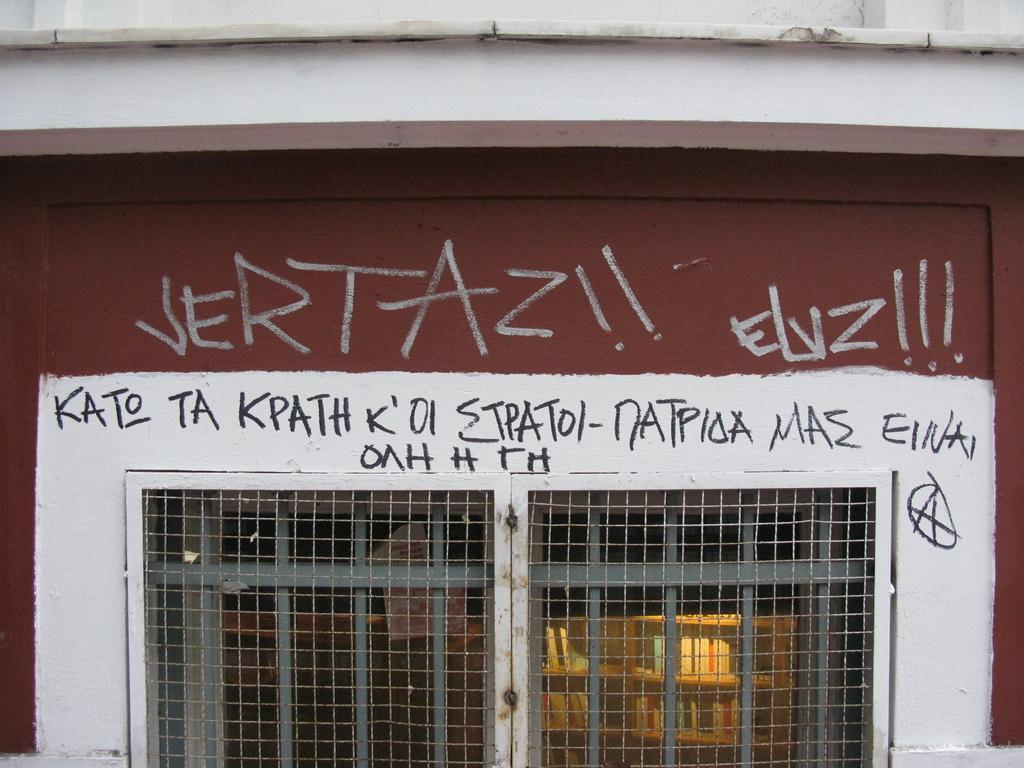Please provide a concise description of this image. In this image, we can see a wall with the fence doors. 